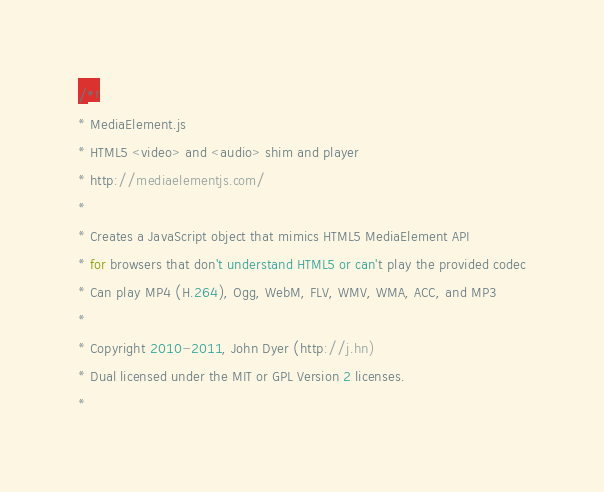Convert code to text. <code><loc_0><loc_0><loc_500><loc_500><_JavaScript_>/*!
* MediaElement.js
* HTML5 <video> and <audio> shim and player
* http://mediaelementjs.com/
*
* Creates a JavaScript object that mimics HTML5 MediaElement API
* for browsers that don't understand HTML5 or can't play the provided codec
* Can play MP4 (H.264), Ogg, WebM, FLV, WMV, WMA, ACC, and MP3
*
* Copyright 2010-2011, John Dyer (http://j.hn)
* Dual licensed under the MIT or GPL Version 2 licenses.
*</code> 